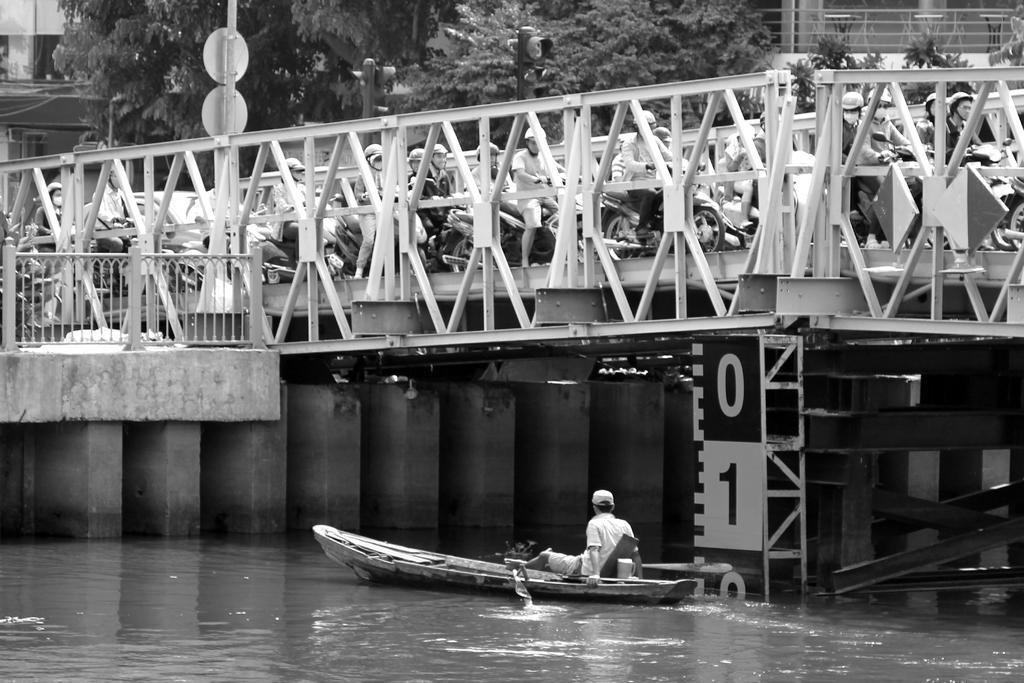Could you give a brief overview of what you see in this image? This image is taken outdoors. This image is a black and white image. At the bottom of the image there is a river with water. At the top of the image there is a building. There are a few trees. In the middle of the image there is a bridge with pillars and railings. There is a sign board and many people are moving on the vehicles. There are many vehicles moving on the bridge. There is a board with a text on it and a man is sitting on the boat and sailing on the river. 